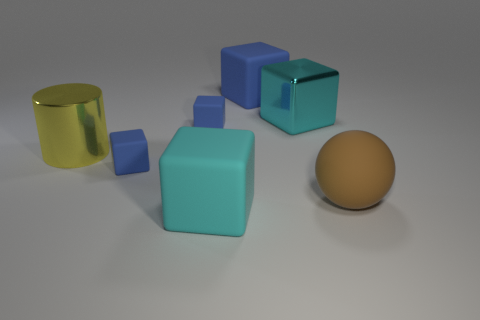How many other things are the same size as the yellow object?
Your answer should be compact. 4. There is a object that is both in front of the big yellow shiny object and behind the big brown rubber object; what size is it?
Your response must be concise. Small. There is a big cylinder; is its color the same as the tiny block behind the big yellow object?
Your answer should be compact. No. Are there any other large metal objects of the same shape as the large yellow metal thing?
Offer a very short reply. No. How many objects are either tiny cyan matte things or big matte things that are in front of the big yellow cylinder?
Provide a short and direct response. 2. How many other objects are the same material as the large brown object?
Offer a terse response. 4. What number of things are either large cyan rubber blocks or rubber balls?
Provide a short and direct response. 2. Is the number of big yellow metal cylinders behind the cyan shiny thing greater than the number of tiny blue matte objects that are in front of the big cylinder?
Ensure brevity in your answer.  No. Do the big rubber cube that is in front of the brown sphere and the large rubber object right of the cyan shiny object have the same color?
Give a very brief answer. No. There is a cyan block to the right of the big rubber cube in front of the large blue block on the left side of the big sphere; what size is it?
Make the answer very short. Large. 